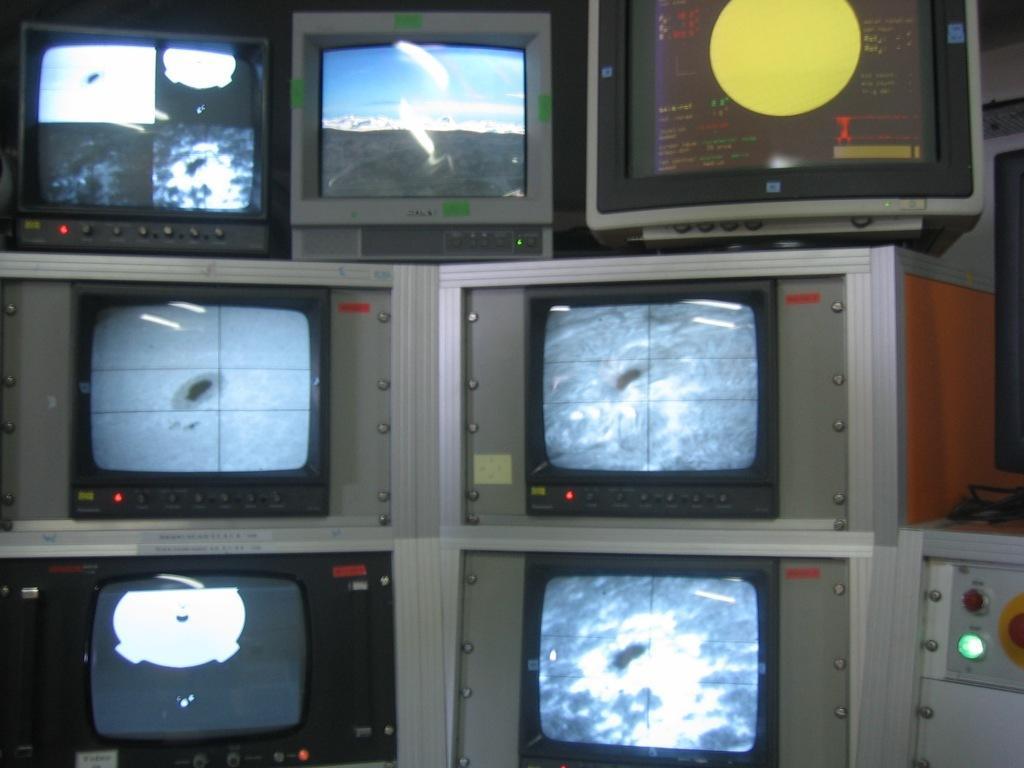Describe this image in one or two sentences. This image is taken indoors. In the middle of the image there are many screens with a few images and text. On the right side of the image there is a machine with two buttons and there is a wall. 